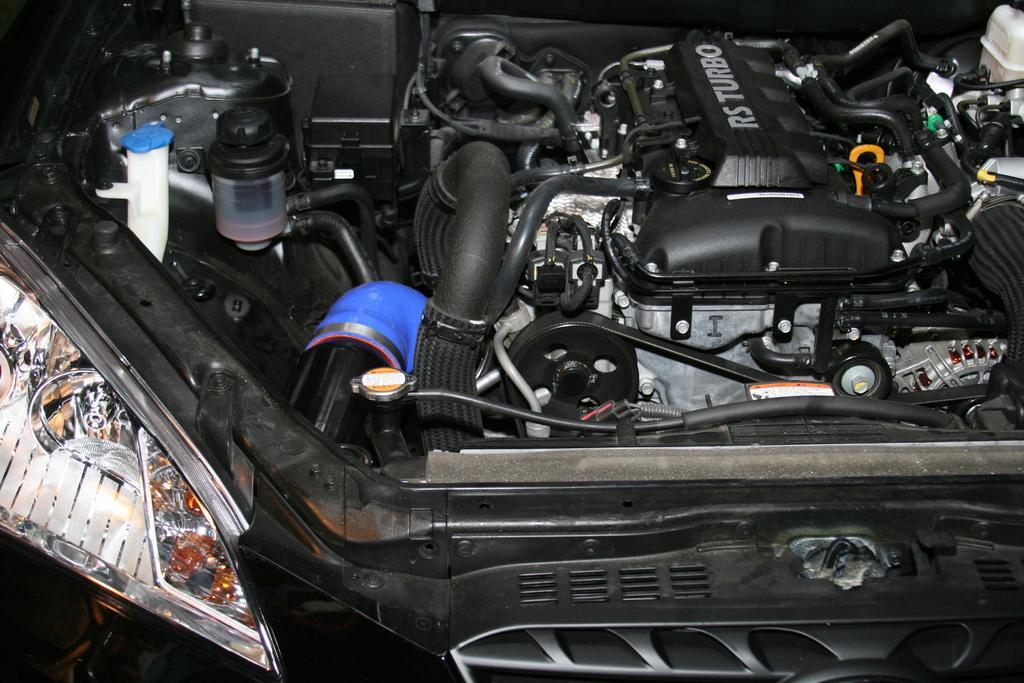How would you summarize this image in a sentence or two? In this image I can see the engine of a vehicle with some text written on it. 